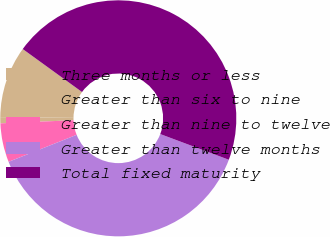Convert chart to OTSL. <chart><loc_0><loc_0><loc_500><loc_500><pie_chart><fcel>Three months or less<fcel>Greater than six to nine<fcel>Greater than nine to twelve<fcel>Greater than twelve months<fcel>Total fixed maturity<nl><fcel>9.82%<fcel>0.84%<fcel>5.33%<fcel>38.28%<fcel>45.72%<nl></chart> 